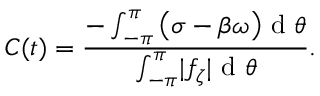<formula> <loc_0><loc_0><loc_500><loc_500>C ( t ) = \frac { - \int _ { - \pi } ^ { \pi } \left ( \sigma - \beta \omega \right ) d \theta } { \int _ { - \pi } ^ { \pi } | f _ { \zeta } | d \theta } .</formula> 